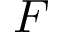<formula> <loc_0><loc_0><loc_500><loc_500>F</formula> 